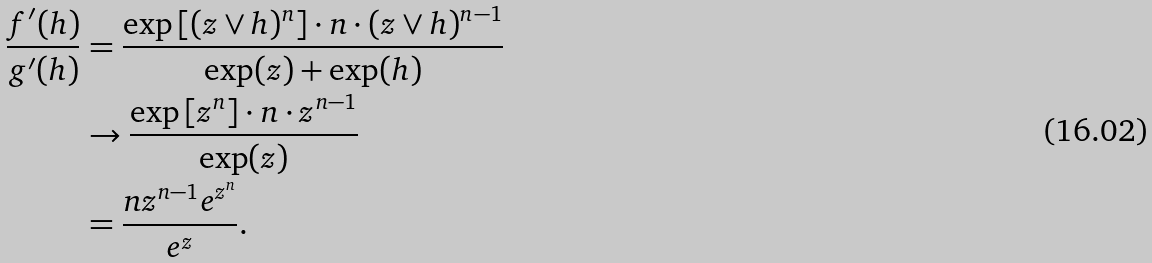<formula> <loc_0><loc_0><loc_500><loc_500>\frac { f ^ { \prime } ( h ) } { g ^ { \prime } ( h ) } & = \frac { \exp \left [ ( z \vee h ) ^ { n } \right ] \cdot n \cdot ( z \vee h ) ^ { n - 1 } } { \exp ( z ) + \exp ( h ) } \\ & \to \frac { \exp \left [ z ^ { n } \right ] \cdot n \cdot z ^ { n - 1 } } { \exp ( z ) } \\ & = \frac { n z ^ { n - 1 } e ^ { z ^ { n } } } { e ^ { z } } .</formula> 